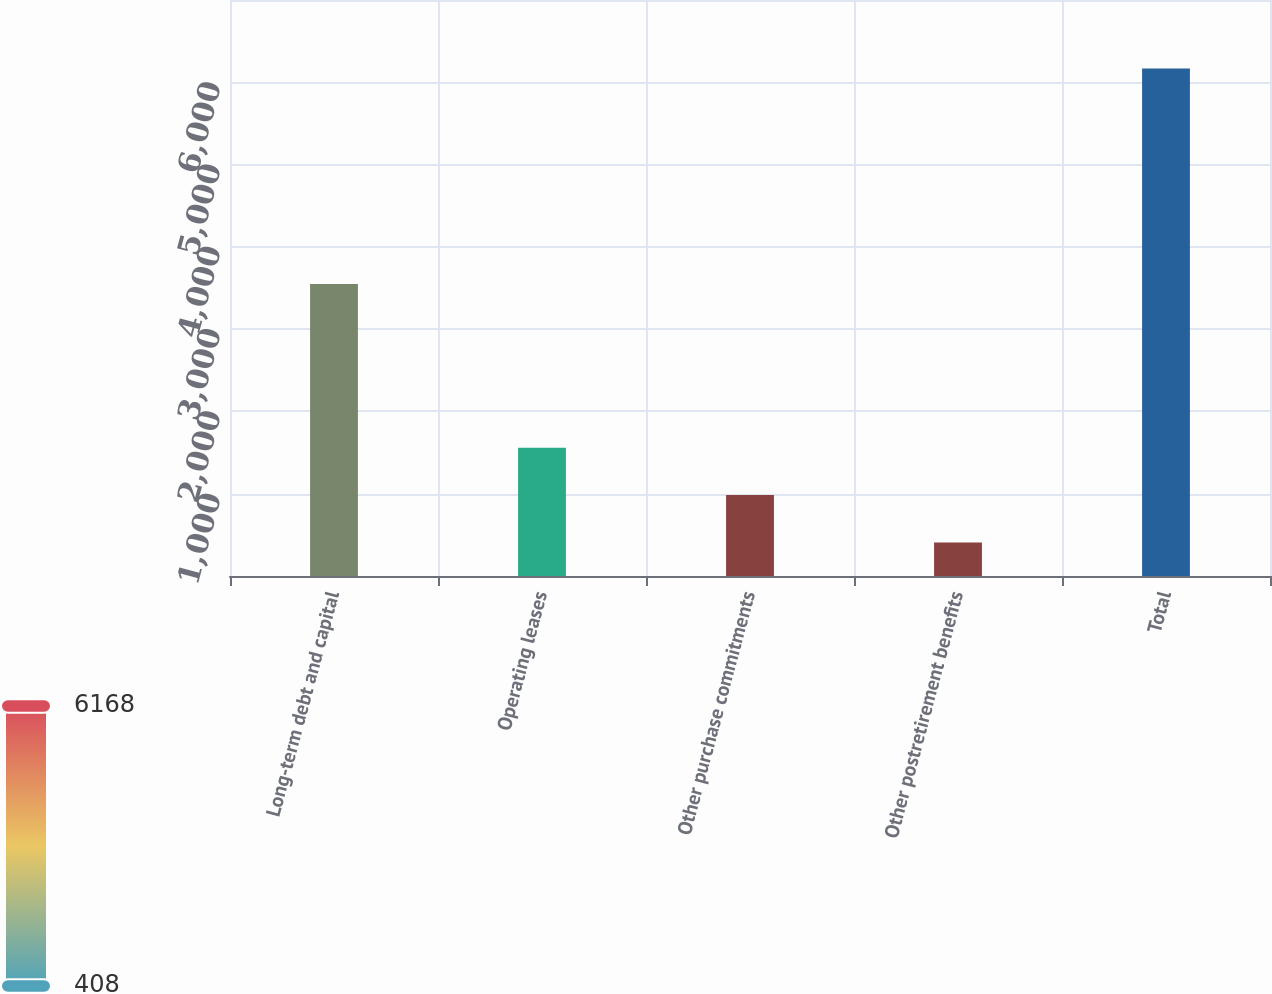<chart> <loc_0><loc_0><loc_500><loc_500><bar_chart><fcel>Long-term debt and capital<fcel>Operating leases<fcel>Other purchase commitments<fcel>Other postretirement benefits<fcel>Total<nl><fcel>3550<fcel>1560<fcel>984<fcel>408<fcel>6168<nl></chart> 